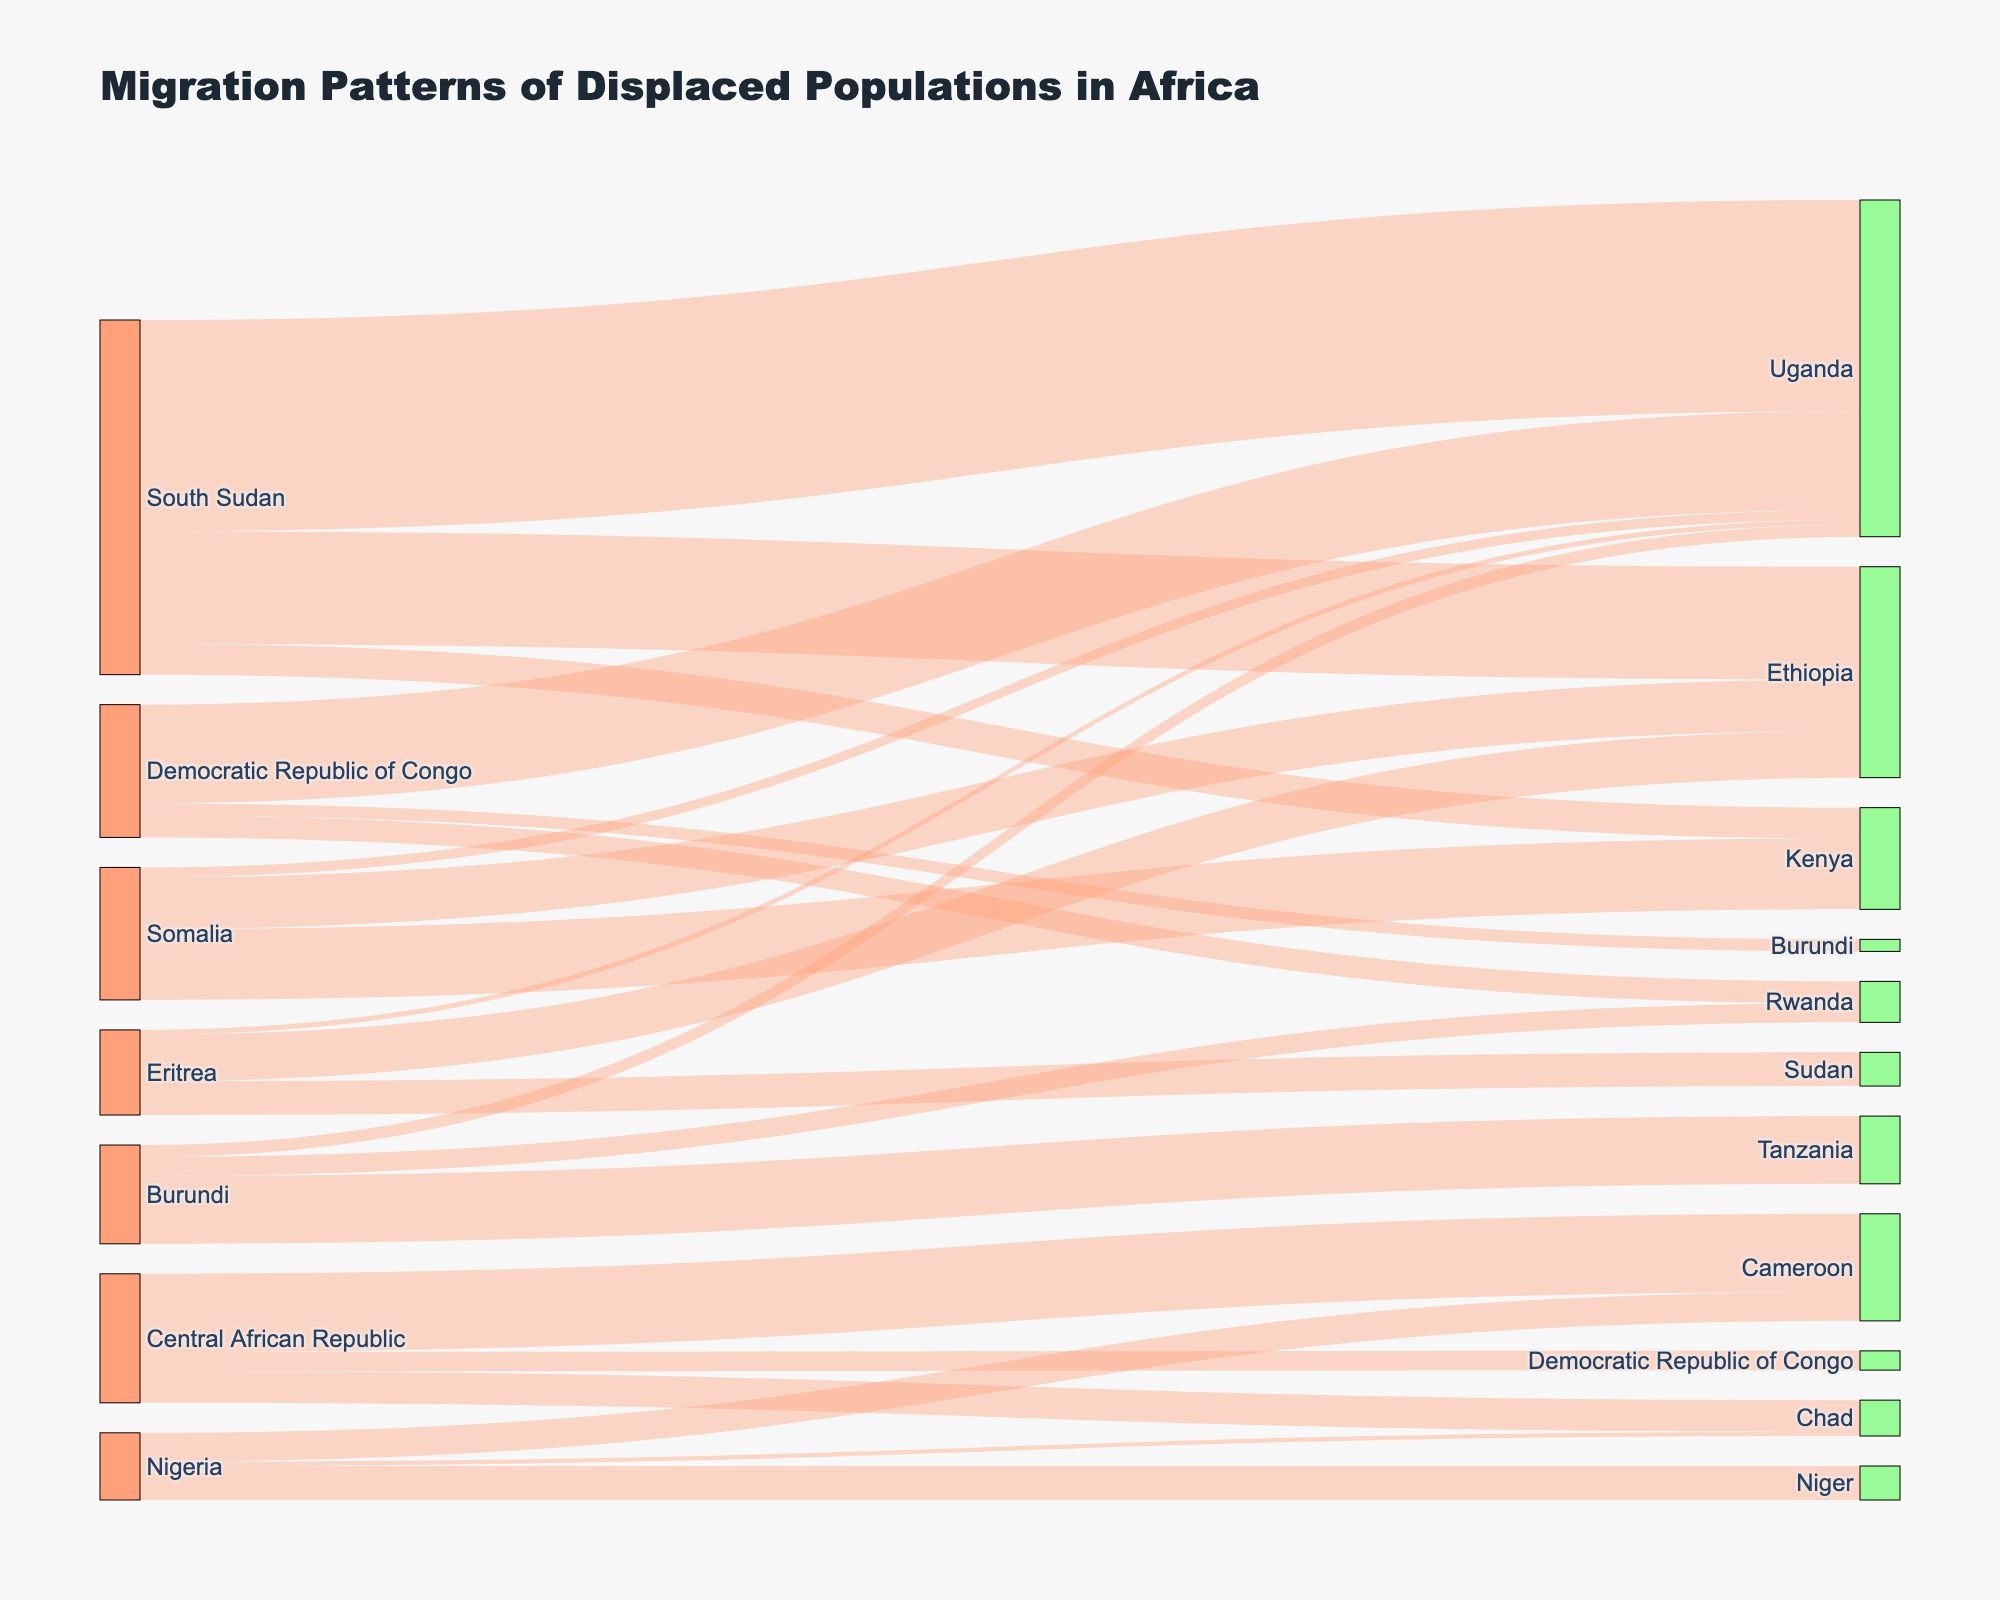What's the title of the diagram? The title is usually placed at the top of the diagram, indicating the main subject it represents. To find the answer, simply look at the top of the figure.
Answer: Migration Patterns of Displaced Populations in Africa Which country has the largest flow of displaced populations to Uganda? Look at the nodes connected to Uganda and identify the one with the highest value. Find 'Uganda' in the target list, then trace back to the source country with the largest corresponding value.
Answer: South Sudan How many countries are shown as sources of displaced populations? Each country's identifier on the left side of the Sankey diagram represents a source of displaced populations. Count each distinct node on the left side.
Answer: 7 What is the total displaced population from Burundi? Sum the values of all connections originating from Burundi. That's 253,000 (to Tanzania) + 71,000 (to Rwanda) + 45,000 (to Uganda). The total value is 253,000 + 71,000 + 45,000.
Answer: 369,000 Which destination country receives displaced populations from the highest number of different sources? Count the number of connections (or source nodes) leading to each target country and identify the one with the highest count.
Answer: Uganda What is the combined displaced population from Nigeria that has moved to Niger and Cameroon? Find the values associated with Nigeria to both Niger and Cameroon. That's 127,000 (to Niger) + 108,000 (to Cameroon). Sum these values to get the total.
Answer: 235,000 Which source country has the smallest migration flow to any single destination? Identify the smallest value among all connections (links) in the diagram and find the corresponding source country.
Answer: Nigeria How does the migration flow from South Sudan to Kenya compare to that from Somalia to Uganda? Look at both values and compare them. South Sudan to Kenya is 115,000, while Somalia to Uganda is 37,000. Determine which is larger.
Answer: South Sudan to Kenya is larger List all destination countries that receive displaced populations from the Democratic Republic of Congo. Identify all nodes connected to the Democratic Republic of Congo on the left and list them. They are Uganda, Rwanda, and Burundi.
Answer: Uganda, Rwanda, Burundi What proportion of Central African Republic's displaced populations move to Cameroon compared to the total displaced from Central African Republic? First sum the total displaced population from the Central African Republic: 292,000 (to Cameroon) + 118,000 (to Chad) + 72,000 (to DRC). Then, calculate the proportion that goes to Cameroon: 292,000/ (292,000 + 118,000 + 72,000).
Answer: 292,000 / 482,000 = 0.606 (approximately 60.6%) 